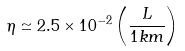Convert formula to latex. <formula><loc_0><loc_0><loc_500><loc_500>\eta \simeq 2 . 5 \times 1 0 ^ { - 2 } \left ( \frac { L } { 1 k m } \right )</formula> 